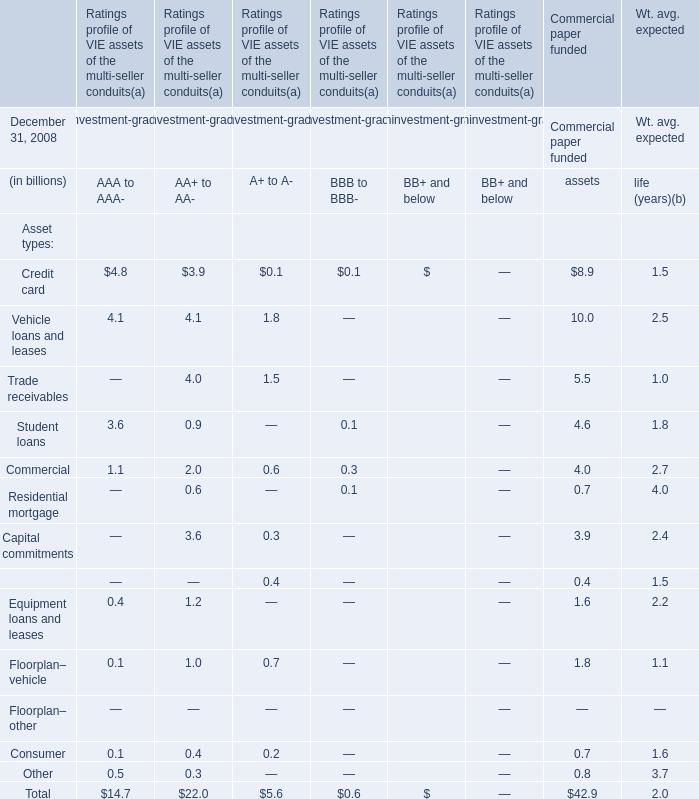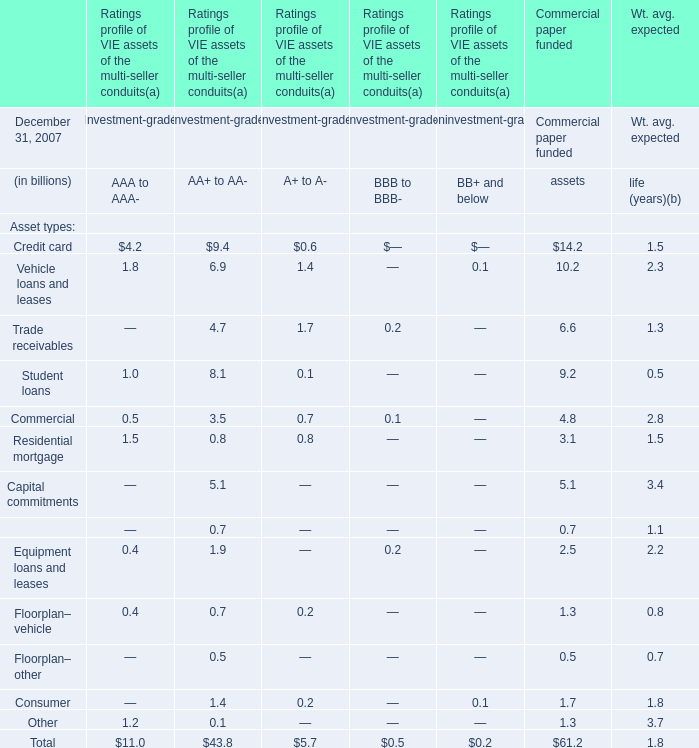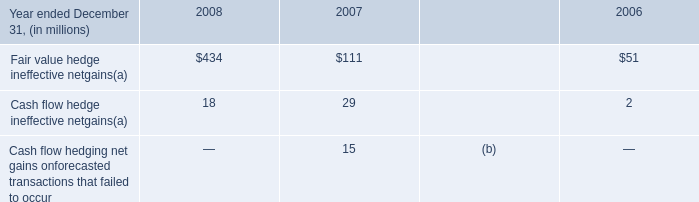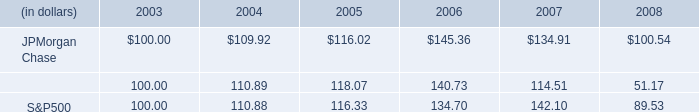What do all Assets for Commercial paper funded assets at December 31, 2007 sum up, excluding those ones less than 10 billion? (in billion) 
Computations: (14.2 + 10.2)
Answer: 24.4. 